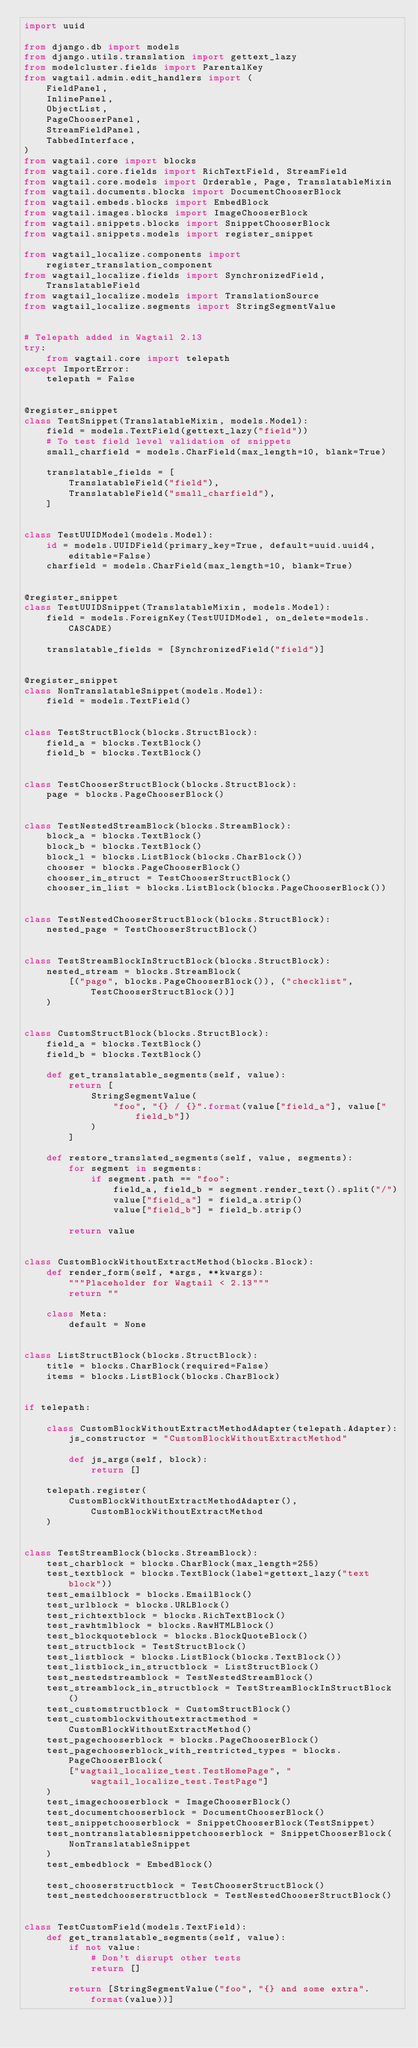Convert code to text. <code><loc_0><loc_0><loc_500><loc_500><_Python_>import uuid

from django.db import models
from django.utils.translation import gettext_lazy
from modelcluster.fields import ParentalKey
from wagtail.admin.edit_handlers import (
    FieldPanel,
    InlinePanel,
    ObjectList,
    PageChooserPanel,
    StreamFieldPanel,
    TabbedInterface,
)
from wagtail.core import blocks
from wagtail.core.fields import RichTextField, StreamField
from wagtail.core.models import Orderable, Page, TranslatableMixin
from wagtail.documents.blocks import DocumentChooserBlock
from wagtail.embeds.blocks import EmbedBlock
from wagtail.images.blocks import ImageChooserBlock
from wagtail.snippets.blocks import SnippetChooserBlock
from wagtail.snippets.models import register_snippet

from wagtail_localize.components import register_translation_component
from wagtail_localize.fields import SynchronizedField, TranslatableField
from wagtail_localize.models import TranslationSource
from wagtail_localize.segments import StringSegmentValue


# Telepath added in Wagtail 2.13
try:
    from wagtail.core import telepath
except ImportError:
    telepath = False


@register_snippet
class TestSnippet(TranslatableMixin, models.Model):
    field = models.TextField(gettext_lazy("field"))
    # To test field level validation of snippets
    small_charfield = models.CharField(max_length=10, blank=True)

    translatable_fields = [
        TranslatableField("field"),
        TranslatableField("small_charfield"),
    ]


class TestUUIDModel(models.Model):
    id = models.UUIDField(primary_key=True, default=uuid.uuid4, editable=False)
    charfield = models.CharField(max_length=10, blank=True)


@register_snippet
class TestUUIDSnippet(TranslatableMixin, models.Model):
    field = models.ForeignKey(TestUUIDModel, on_delete=models.CASCADE)

    translatable_fields = [SynchronizedField("field")]


@register_snippet
class NonTranslatableSnippet(models.Model):
    field = models.TextField()


class TestStructBlock(blocks.StructBlock):
    field_a = blocks.TextBlock()
    field_b = blocks.TextBlock()


class TestChooserStructBlock(blocks.StructBlock):
    page = blocks.PageChooserBlock()


class TestNestedStreamBlock(blocks.StreamBlock):
    block_a = blocks.TextBlock()
    block_b = blocks.TextBlock()
    block_l = blocks.ListBlock(blocks.CharBlock())
    chooser = blocks.PageChooserBlock()
    chooser_in_struct = TestChooserStructBlock()
    chooser_in_list = blocks.ListBlock(blocks.PageChooserBlock())


class TestNestedChooserStructBlock(blocks.StructBlock):
    nested_page = TestChooserStructBlock()


class TestStreamBlockInStructBlock(blocks.StructBlock):
    nested_stream = blocks.StreamBlock(
        [("page", blocks.PageChooserBlock()), ("checklist", TestChooserStructBlock())]
    )


class CustomStructBlock(blocks.StructBlock):
    field_a = blocks.TextBlock()
    field_b = blocks.TextBlock()

    def get_translatable_segments(self, value):
        return [
            StringSegmentValue(
                "foo", "{} / {}".format(value["field_a"], value["field_b"])
            )
        ]

    def restore_translated_segments(self, value, segments):
        for segment in segments:
            if segment.path == "foo":
                field_a, field_b = segment.render_text().split("/")
                value["field_a"] = field_a.strip()
                value["field_b"] = field_b.strip()

        return value


class CustomBlockWithoutExtractMethod(blocks.Block):
    def render_form(self, *args, **kwargs):
        """Placeholder for Wagtail < 2.13"""
        return ""

    class Meta:
        default = None


class ListStructBlock(blocks.StructBlock):
    title = blocks.CharBlock(required=False)
    items = blocks.ListBlock(blocks.CharBlock)


if telepath:

    class CustomBlockWithoutExtractMethodAdapter(telepath.Adapter):
        js_constructor = "CustomBlockWithoutExtractMethod"

        def js_args(self, block):
            return []

    telepath.register(
        CustomBlockWithoutExtractMethodAdapter(), CustomBlockWithoutExtractMethod
    )


class TestStreamBlock(blocks.StreamBlock):
    test_charblock = blocks.CharBlock(max_length=255)
    test_textblock = blocks.TextBlock(label=gettext_lazy("text block"))
    test_emailblock = blocks.EmailBlock()
    test_urlblock = blocks.URLBlock()
    test_richtextblock = blocks.RichTextBlock()
    test_rawhtmlblock = blocks.RawHTMLBlock()
    test_blockquoteblock = blocks.BlockQuoteBlock()
    test_structblock = TestStructBlock()
    test_listblock = blocks.ListBlock(blocks.TextBlock())
    test_listblock_in_structblock = ListStructBlock()
    test_nestedstreamblock = TestNestedStreamBlock()
    test_streamblock_in_structblock = TestStreamBlockInStructBlock()
    test_customstructblock = CustomStructBlock()
    test_customblockwithoutextractmethod = CustomBlockWithoutExtractMethod()
    test_pagechooserblock = blocks.PageChooserBlock()
    test_pagechooserblock_with_restricted_types = blocks.PageChooserBlock(
        ["wagtail_localize_test.TestHomePage", "wagtail_localize_test.TestPage"]
    )
    test_imagechooserblock = ImageChooserBlock()
    test_documentchooserblock = DocumentChooserBlock()
    test_snippetchooserblock = SnippetChooserBlock(TestSnippet)
    test_nontranslatablesnippetchooserblock = SnippetChooserBlock(
        NonTranslatableSnippet
    )
    test_embedblock = EmbedBlock()

    test_chooserstructblock = TestChooserStructBlock()
    test_nestedchooserstructblock = TestNestedChooserStructBlock()


class TestCustomField(models.TextField):
    def get_translatable_segments(self, value):
        if not value:
            # Don't disrupt other tests
            return []

        return [StringSegmentValue("foo", "{} and some extra".format(value))]

</code> 